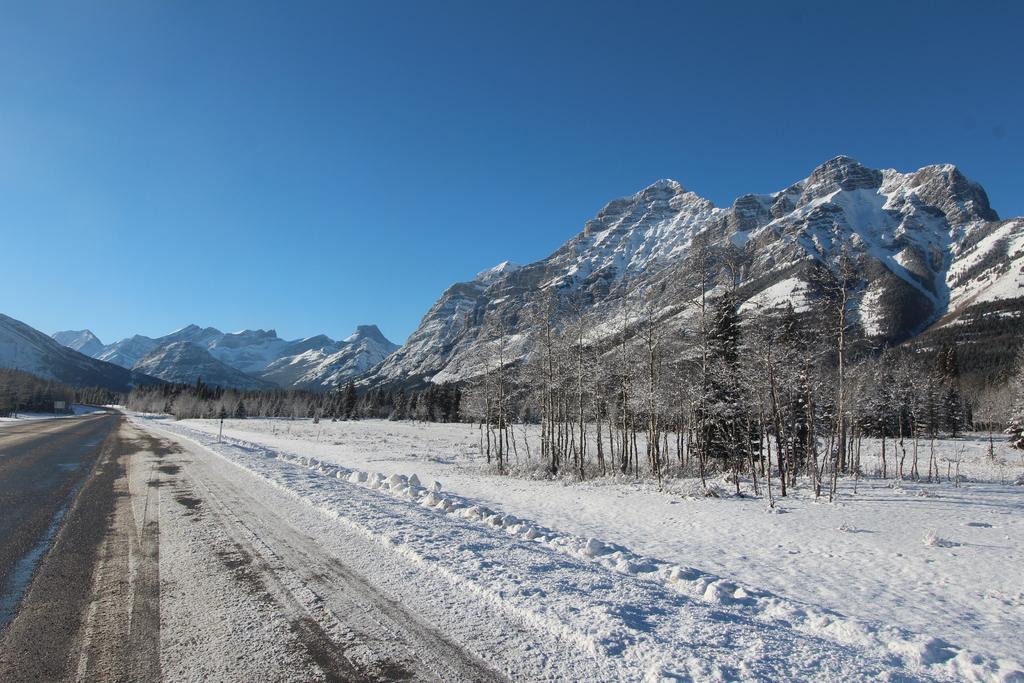Can you describe this image briefly? In this image at the bottom there is a walkway and snow, and also we could see some trees and mountains. And at the top there is sky. 